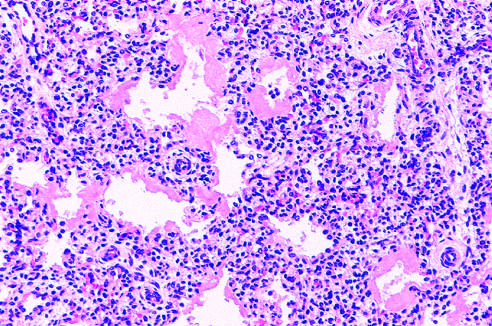s this hyaline membrane disease?
Answer the question using a single word or phrase. Yes 